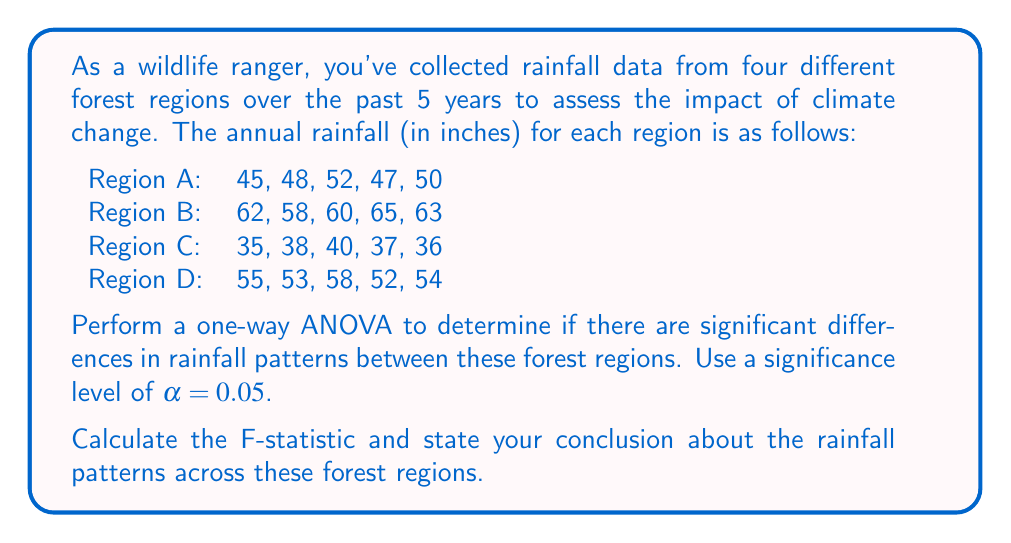Show me your answer to this math problem. To perform a one-way ANOVA, we'll follow these steps:

1. Calculate the sum of squares between groups (SSB) and within groups (SSW).
2. Calculate the degrees of freedom between groups (dfB) and within groups (dfW).
3. Calculate the mean squares between groups (MSB) and within groups (MSW).
4. Calculate the F-statistic.
5. Compare the F-statistic to the critical F-value.

Step 1: Calculate SSB and SSW

First, we need to calculate the grand mean and group means:

Grand mean: $\bar{X} = \frac{(45+48+52+47+50+62+58+60+65+63+35+38+40+37+36+55+53+58+52+54)}{20} = 50.4$

Group means:
$\bar{X}_A = 48.4$
$\bar{X}_B = 61.6$
$\bar{X}_C = 37.2$
$\bar{X}_D = 54.4$

Now, we can calculate SSB:

$$SSB = \sum_{i=1}^k n_i(\bar{X}_i - \bar{X})^2$$
$$SSB = 5(48.4 - 50.4)^2 + 5(61.6 - 50.4)^2 + 5(37.2 - 50.4)^2 + 5(54.4 - 50.4)^2 = 1848.8$$

For SSW, we calculate the sum of squared deviations within each group:

$$SSW = \sum_{i=1}^k \sum_{j=1}^{n_i} (X_{ij} - \bar{X}_i)^2$$
$$SSW = 26.8 + 26.8 + 14.8 + 30.8 = 99.2$$

Step 2: Calculate degrees of freedom

dfB = k - 1 = 4 - 1 = 3
dfW = N - k = 20 - 4 = 16

Step 3: Calculate mean squares

$$MSB = \frac{SSB}{dfB} = \frac{1848.8}{3} = 616.27$$
$$MSW = \frac{SSW}{dfW} = \frac{99.2}{16} = 6.2$$

Step 4: Calculate F-statistic

$$F = \frac{MSB}{MSW} = \frac{616.27}{6.2} = 99.40$$

Step 5: Compare F-statistic to critical F-value

The critical F-value for α = 0.05, dfB = 3, and dfW = 16 is approximately 3.24.

Since our calculated F-statistic (99.40) is much larger than the critical F-value (3.24), we reject the null hypothesis.
Answer: The calculated F-statistic is 99.40. Since this value is greater than the critical F-value of 3.24, we conclude that there are significant differences in rainfall patterns between the forest regions at the 0.05 significance level. 